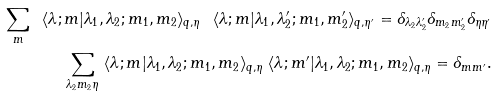Convert formula to latex. <formula><loc_0><loc_0><loc_500><loc_500>\sum _ { m } \ \langle \lambda ; m | \lambda _ { 1 } , \lambda _ { 2 } ; m _ { 1 } , m _ { 2 } \rangle _ { q , \eta } \ \langle \lambda ; m | \lambda _ { 1 } , \lambda ^ { \prime } _ { 2 } ; m _ { 1 } , m ^ { \prime } _ { 2 } \rangle _ { q , \eta ^ { \prime } } = \delta _ { \lambda _ { 2 } \lambda ^ { \prime } _ { 2 } } \delta _ { m _ { 2 } m ^ { \prime } _ { 2 } } \delta _ { \eta \eta ^ { \prime } } \\ \sum _ { \lambda _ { 2 } m _ { 2 } \eta } \ \langle \lambda ; m | \lambda _ { 1 } , \lambda _ { 2 } ; m _ { 1 } , m _ { 2 } \rangle _ { q , \eta } \ \langle \lambda ; m ^ { \prime } | \lambda _ { 1 } , \lambda _ { 2 } ; m _ { 1 } , m _ { 2 } \rangle _ { q , \eta } = \delta _ { m m ^ { \prime } } .</formula> 